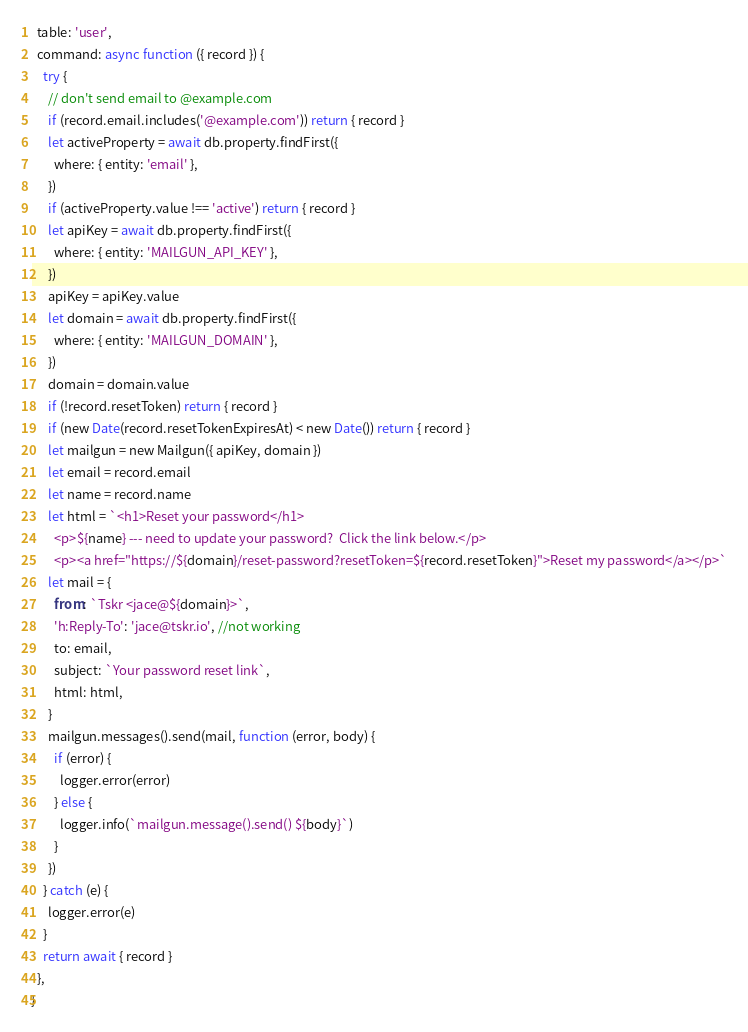<code> <loc_0><loc_0><loc_500><loc_500><_JavaScript_>  table: 'user',
  command: async function ({ record }) {
    try {
      // don't send email to @example.com
      if (record.email.includes('@example.com')) return { record }
      let activeProperty = await db.property.findFirst({
        where: { entity: 'email' },
      })
      if (activeProperty.value !== 'active') return { record }
      let apiKey = await db.property.findFirst({
        where: { entity: 'MAILGUN_API_KEY' },
      })
      apiKey = apiKey.value
      let domain = await db.property.findFirst({
        where: { entity: 'MAILGUN_DOMAIN' },
      })
      domain = domain.value
      if (!record.resetToken) return { record }
      if (new Date(record.resetTokenExpiresAt) < new Date()) return { record }
      let mailgun = new Mailgun({ apiKey, domain })
      let email = record.email
      let name = record.name
      let html = `<h1>Reset your password</h1>
        <p>${name} --- need to update your password?  Click the link below.</p>
        <p><a href="https://${domain}/reset-password?resetToken=${record.resetToken}">Reset my password</a></p>`
      let mail = {
        from: `Tskr <jace@${domain}>`,
        'h:Reply-To': 'jace@tskr.io', //not working
        to: email,
        subject: `Your password reset link`,
        html: html,
      }
      mailgun.messages().send(mail, function (error, body) {
        if (error) {
          logger.error(error)
        } else {
          logger.info(`mailgun.message().send() ${body}`)
        }
      })
    } catch (e) {
      logger.error(e)
    }
    return await { record }
  },
}
</code> 